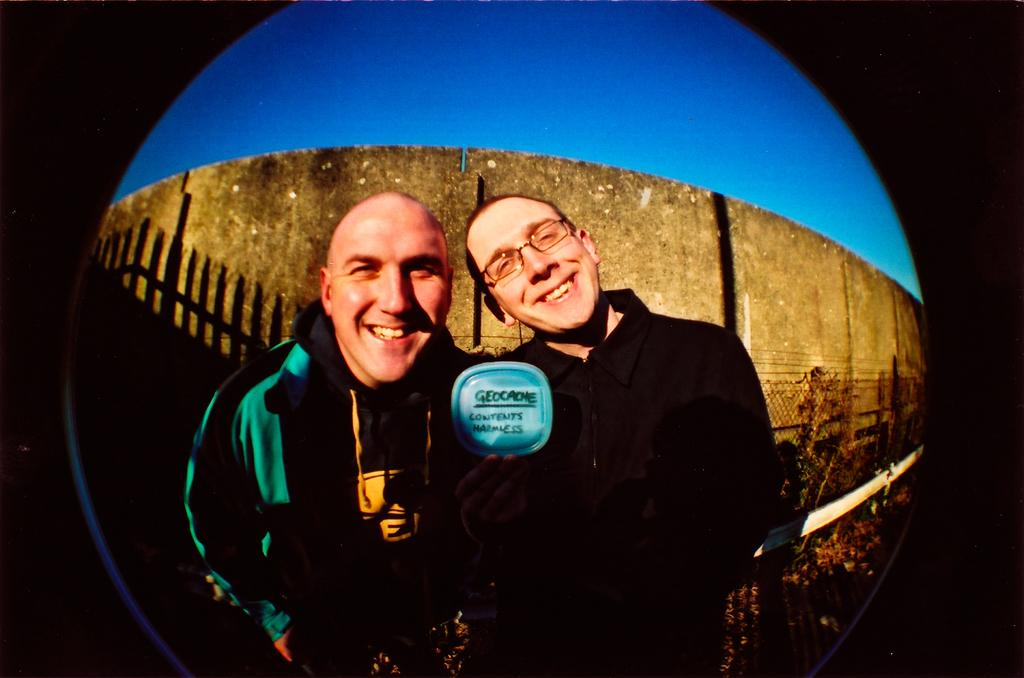How many people are in the image? There are two persons in the image. What is the facial expression of the persons in the image? The persons are smiling. Where are the persons located in the image? The persons are standing on the ground. What can be seen in the background of the image? There is a sky, a wall, and metal rods visible in the background of the image. What type of leather is being used to make the fairies' wings in the image? There are no fairies or wings present in the image, so there is no leather being used for them. 